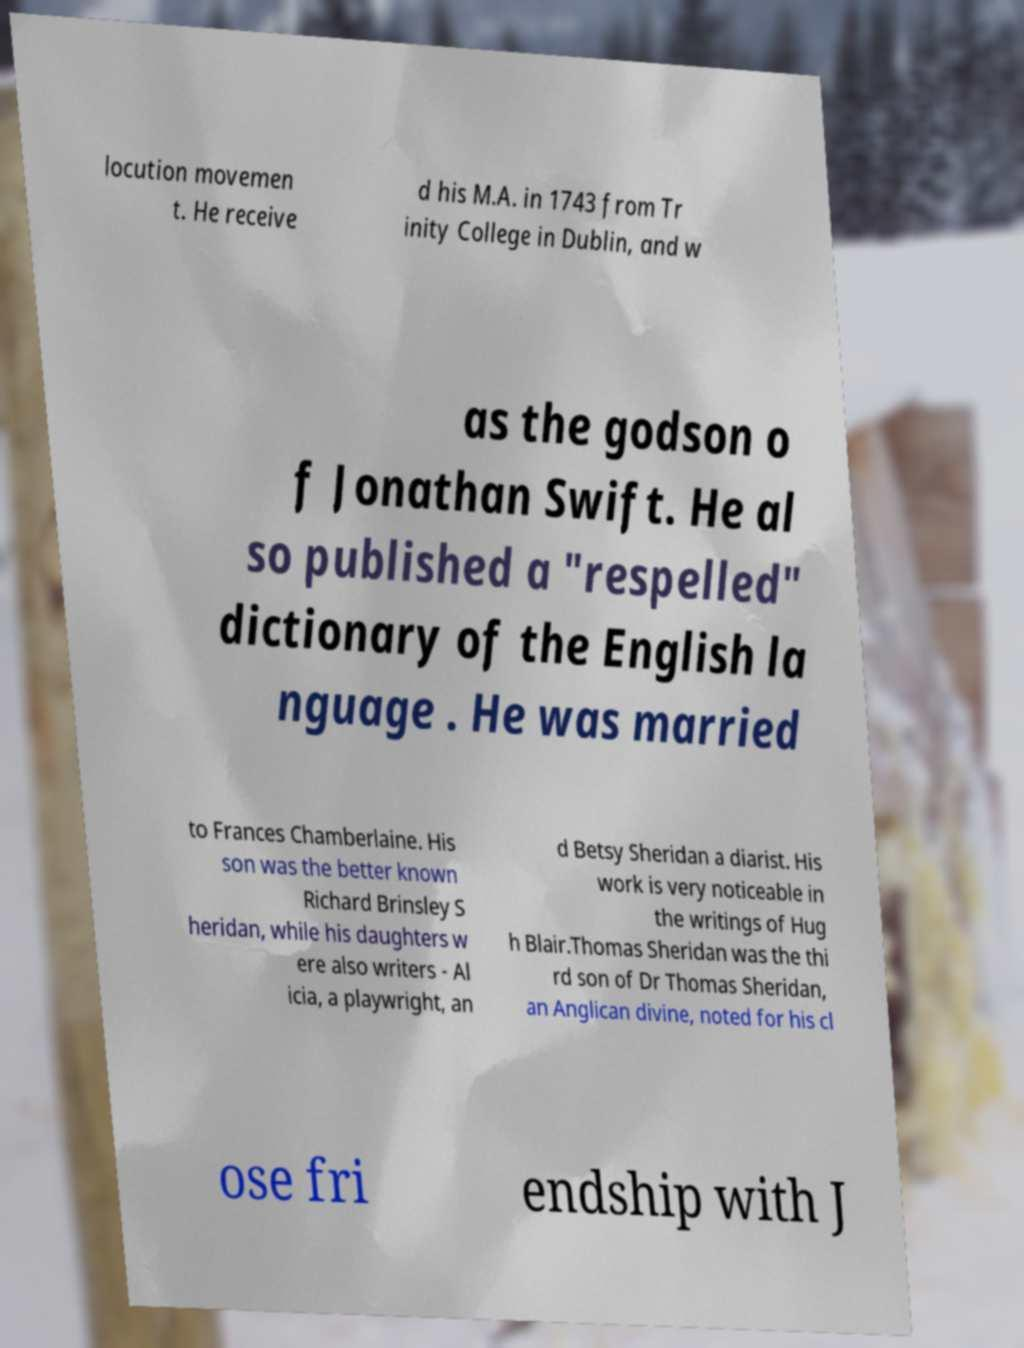I need the written content from this picture converted into text. Can you do that? locution movemen t. He receive d his M.A. in 1743 from Tr inity College in Dublin, and w as the godson o f Jonathan Swift. He al so published a "respelled" dictionary of the English la nguage . He was married to Frances Chamberlaine. His son was the better known Richard Brinsley S heridan, while his daughters w ere also writers - Al icia, a playwright, an d Betsy Sheridan a diarist. His work is very noticeable in the writings of Hug h Blair.Thomas Sheridan was the thi rd son of Dr Thomas Sheridan, an Anglican divine, noted for his cl ose fri endship with J 